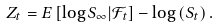Convert formula to latex. <formula><loc_0><loc_0><loc_500><loc_500>Z _ { t } = E \left [ \log S _ { \infty } | \mathcal { F } _ { t } \right ] - \log \left ( S _ { t } \right ) .</formula> 